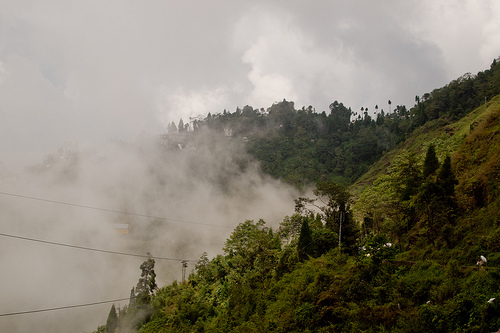<image>
Can you confirm if the mountain is behind the tree? Yes. From this viewpoint, the mountain is positioned behind the tree, with the tree partially or fully occluding the mountain. 